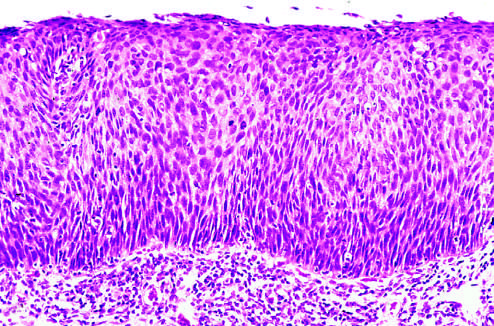s the prominent cell in the center field intact?
Answer the question using a single word or phrase. No 